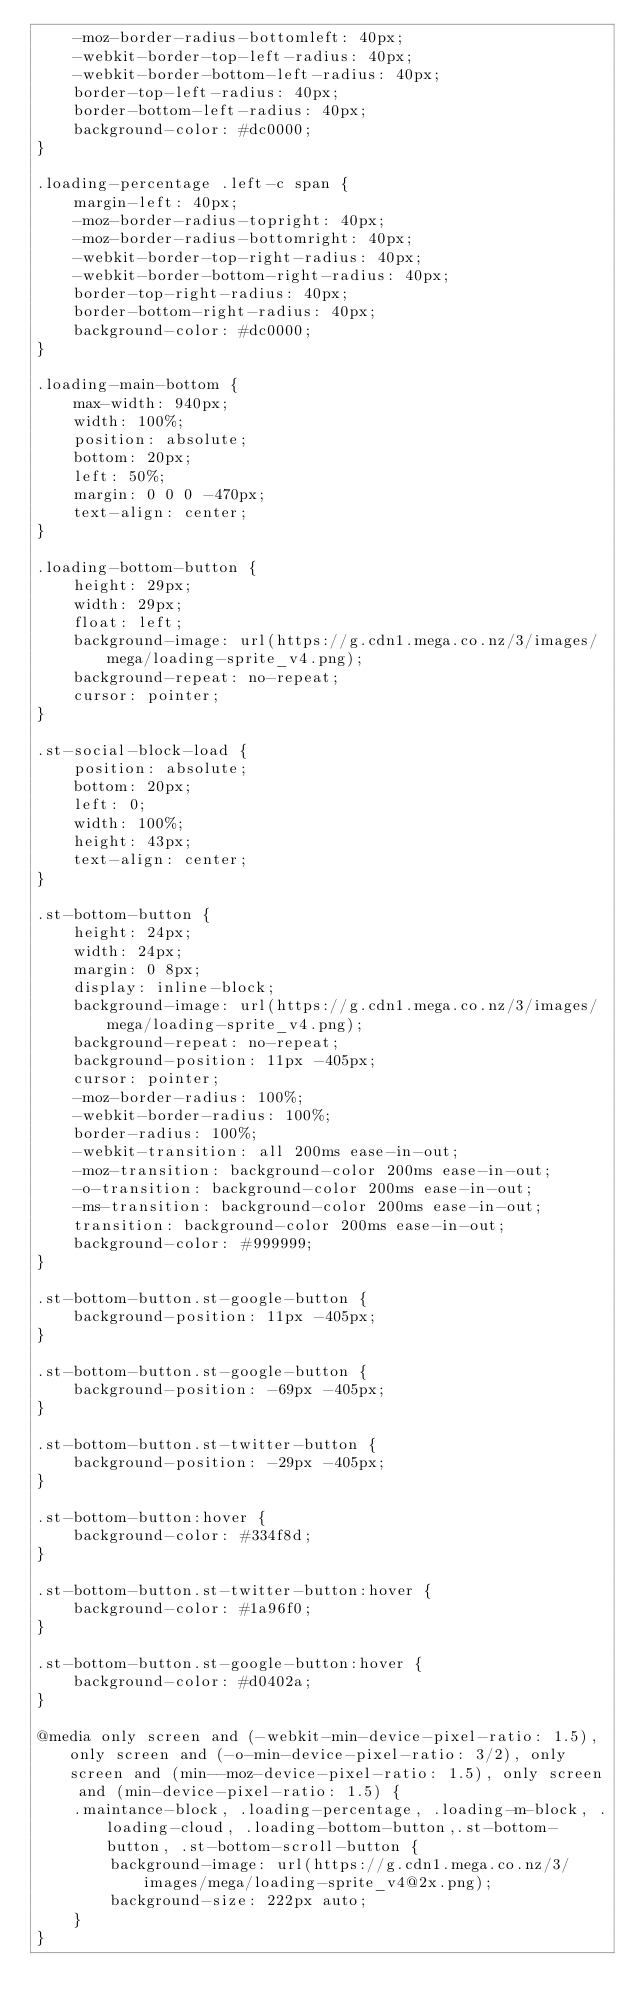<code> <loc_0><loc_0><loc_500><loc_500><_CSS_>    -moz-border-radius-bottomleft: 40px;
    -webkit-border-top-left-radius: 40px;
    -webkit-border-bottom-left-radius: 40px;
    border-top-left-radius: 40px;
    border-bottom-left-radius: 40px;
    background-color: #dc0000;
}

.loading-percentage .left-c span {
    margin-left: 40px;
    -moz-border-radius-topright: 40px;
    -moz-border-radius-bottomright: 40px;
    -webkit-border-top-right-radius: 40px;
    -webkit-border-bottom-right-radius: 40px;
    border-top-right-radius: 40px;
    border-bottom-right-radius: 40px;
    background-color: #dc0000;
}

.loading-main-bottom {
    max-width: 940px;
    width: 100%;
    position: absolute;
    bottom: 20px;
    left: 50%;
    margin: 0 0 0 -470px;
    text-align: center;
}

.loading-bottom-button {
    height: 29px;
    width: 29px;
    float: left;
    background-image: url(https://g.cdn1.mega.co.nz/3/images/mega/loading-sprite_v4.png);
    background-repeat: no-repeat;
    cursor: pointer;
}

.st-social-block-load {
    position: absolute;
    bottom: 20px;
    left: 0;
    width: 100%;
    height: 43px;
    text-align: center;
}

.st-bottom-button {
    height: 24px;
    width: 24px;
    margin: 0 8px;
    display: inline-block;
    background-image: url(https://g.cdn1.mega.co.nz/3/images/mega/loading-sprite_v4.png);
    background-repeat: no-repeat;
    background-position: 11px -405px;
    cursor: pointer;
    -moz-border-radius: 100%;
    -webkit-border-radius: 100%;
    border-radius: 100%;
    -webkit-transition: all 200ms ease-in-out;
    -moz-transition: background-color 200ms ease-in-out;
    -o-transition: background-color 200ms ease-in-out;
    -ms-transition: background-color 200ms ease-in-out;
    transition: background-color 200ms ease-in-out;
    background-color: #999999;
}

.st-bottom-button.st-google-button {
    background-position: 11px -405px;
}

.st-bottom-button.st-google-button {
    background-position: -69px -405px;
}

.st-bottom-button.st-twitter-button {
    background-position: -29px -405px;
}

.st-bottom-button:hover {
    background-color: #334f8d;
}

.st-bottom-button.st-twitter-button:hover {
    background-color: #1a96f0;
}

.st-bottom-button.st-google-button:hover {
    background-color: #d0402a;
}

@media only screen and (-webkit-min-device-pixel-ratio: 1.5), only screen and (-o-min-device-pixel-ratio: 3/2), only screen and (min--moz-device-pixel-ratio: 1.5), only screen and (min-device-pixel-ratio: 1.5) {
    .maintance-block, .loading-percentage, .loading-m-block, .loading-cloud, .loading-bottom-button,.st-bottom-button, .st-bottom-scroll-button {
        background-image: url(https://g.cdn1.mega.co.nz/3/images/mega/loading-sprite_v4@2x.png);
        background-size: 222px auto;
    }
}

</code> 